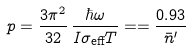<formula> <loc_0><loc_0><loc_500><loc_500>p = \frac { 3 \pi ^ { 2 } } { 3 2 } \, \frac { \hbar { \omega } } { I \sigma _ { \text {eff} } T } = = \frac { 0 . 9 3 } { \bar { n } ^ { \prime } }</formula> 